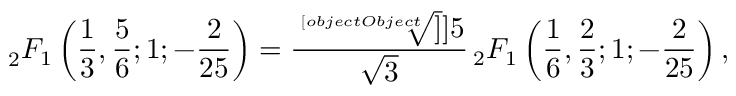Convert formula to latex. <formula><loc_0><loc_0><loc_500><loc_500>_ { 2 } F _ { 1 } \left ( { \frac { 1 } { 3 } } , { \frac { 5 } { 6 } } ; 1 ; { - \frac { 2 } { 2 5 } } \right ) = \frac { \sqrt { [ } [ o b j e c t O b j e c t ] ] ] { 5 } } { \sqrt { 3 } } { \, } _ { 2 } F _ { 1 } \left ( { \frac { 1 } { 6 } } , { \frac { 2 } { 3 } } ; 1 ; { - \frac { 2 } { 2 5 } } \right ) ,</formula> 